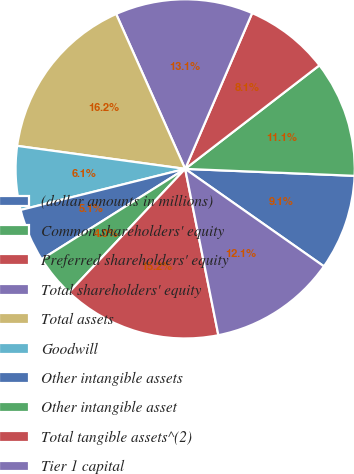Convert chart. <chart><loc_0><loc_0><loc_500><loc_500><pie_chart><fcel>(dollar amounts in millions)<fcel>Common shareholders' equity<fcel>Preferred shareholders' equity<fcel>Total shareholders' equity<fcel>Total assets<fcel>Goodwill<fcel>Other intangible assets<fcel>Other intangible asset<fcel>Total tangible assets^(2)<fcel>Tier 1 capital<nl><fcel>9.09%<fcel>11.11%<fcel>8.08%<fcel>13.13%<fcel>16.16%<fcel>6.06%<fcel>5.05%<fcel>4.04%<fcel>15.15%<fcel>12.12%<nl></chart> 